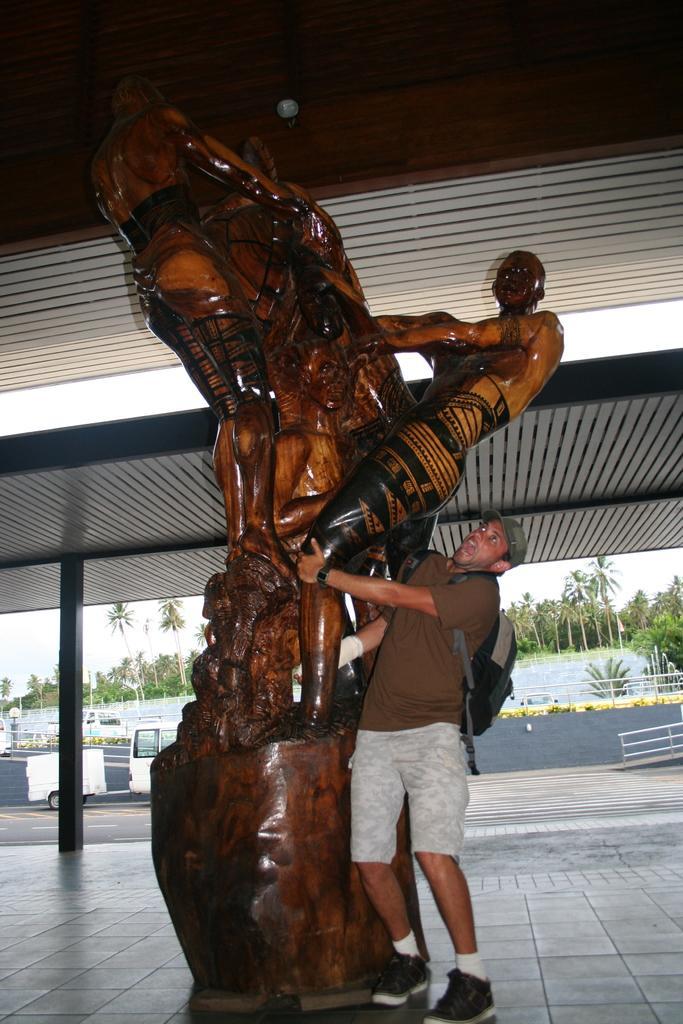Please provide a concise description of this image. This is the picture of a person wearing back pack and standing beside the statue which is in brown color and behind there is a shed and around there are some trees, plants and a fencing. 